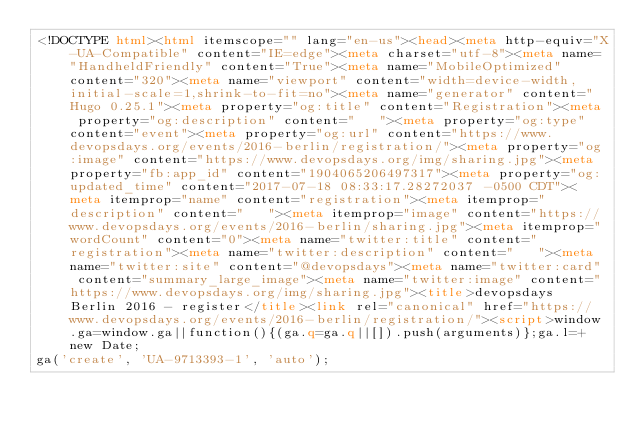<code> <loc_0><loc_0><loc_500><loc_500><_HTML_><!DOCTYPE html><html itemscope="" lang="en-us"><head><meta http-equiv="X-UA-Compatible" content="IE=edge"><meta charset="utf-8"><meta name="HandheldFriendly" content="True"><meta name="MobileOptimized" content="320"><meta name="viewport" content="width=device-width,initial-scale=1,shrink-to-fit=no"><meta name="generator" content="Hugo 0.25.1"><meta property="og:title" content="Registration"><meta property="og:description" content="   "><meta property="og:type" content="event"><meta property="og:url" content="https://www.devopsdays.org/events/2016-berlin/registration/"><meta property="og:image" content="https://www.devopsdays.org/img/sharing.jpg"><meta property="fb:app_id" content="1904065206497317"><meta property="og:updated_time" content="2017-07-18 08:33:17.28272037 -0500 CDT"><meta itemprop="name" content="registration"><meta itemprop="description" content="   "><meta itemprop="image" content="https://www.devopsdays.org/events/2016-berlin/sharing.jpg"><meta itemprop="wordCount" content="0"><meta name="twitter:title" content="registration"><meta name="twitter:description" content="   "><meta name="twitter:site" content="@devopsdays"><meta name="twitter:card" content="summary_large_image"><meta name="twitter:image" content="https://www.devopsdays.org/img/sharing.jpg"><title>devopsdays Berlin 2016 - register</title><link rel="canonical" href="https://www.devopsdays.org/events/2016-berlin/registration/"><script>window.ga=window.ga||function(){(ga.q=ga.q||[]).push(arguments)};ga.l=+new Date;
ga('create', 'UA-9713393-1', 'auto');</code> 